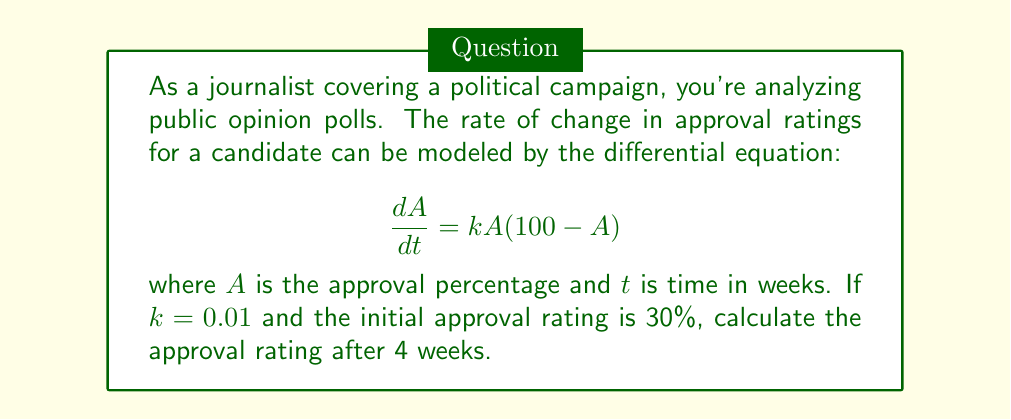Provide a solution to this math problem. 1) We start with the given differential equation:
   $$\frac{dA}{dt} = kA(100-A)$$

2) We're given that $k=0.01$ and the initial condition $A(0) = 30$. We need to solve this equation for $t=4$.

3) This is a separable differential equation. We can rewrite it as:
   $$\frac{dA}{A(100-A)} = 0.01dt$$

4) Integrating both sides:
   $$\int \frac{dA}{A(100-A)} = 0.01 \int dt$$

5) The left side can be integrated using partial fractions:
   $$\frac{1}{100}\ln|\frac{A}{100-A}| = 0.01t + C$$

6) Using the initial condition $A(0) = 30$, we can solve for $C$:
   $$\frac{1}{100}\ln|\frac{30}{70}| = C$$
   $$C = -0.0084$$

7) Now we can write the general solution:
   $$\frac{1}{100}\ln|\frac{A}{100-A}| = 0.01t - 0.0084$$

8) To find $A$ at $t=4$, we substitute $t=4$:
   $$\frac{1}{100}\ln|\frac{A}{100-A}| = 0.04 - 0.0084 = 0.0316$$

9) Solving for $A$:
   $$\ln|\frac{A}{100-A}| = 3.16$$
   $$\frac{A}{100-A} = e^{3.16} \approx 23.57$$

10) Finally:
    $$A = \frac{2357}{24.57} \approx 95.93$$
Answer: 95.93% 